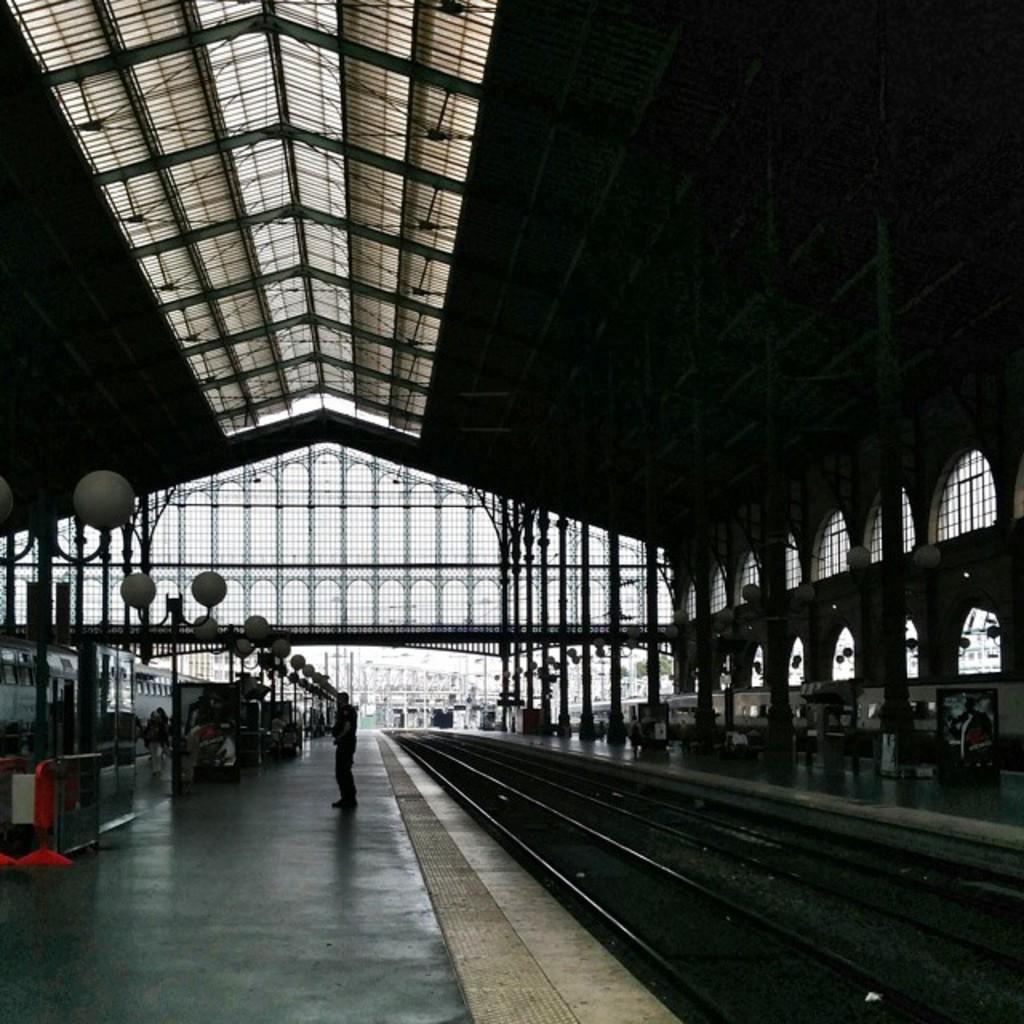Could you give a brief overview of what you see in this image? This image is taken in a railway station. At the top of the image there is a roof. At the bottom of the image there is a platform and a man is standing on the platform. On the left and right sides of the image there are two platforms with pillars, lights and windows. On the left side of the image a train is moving on the track and there are two railway tracks on the right side of the image. 